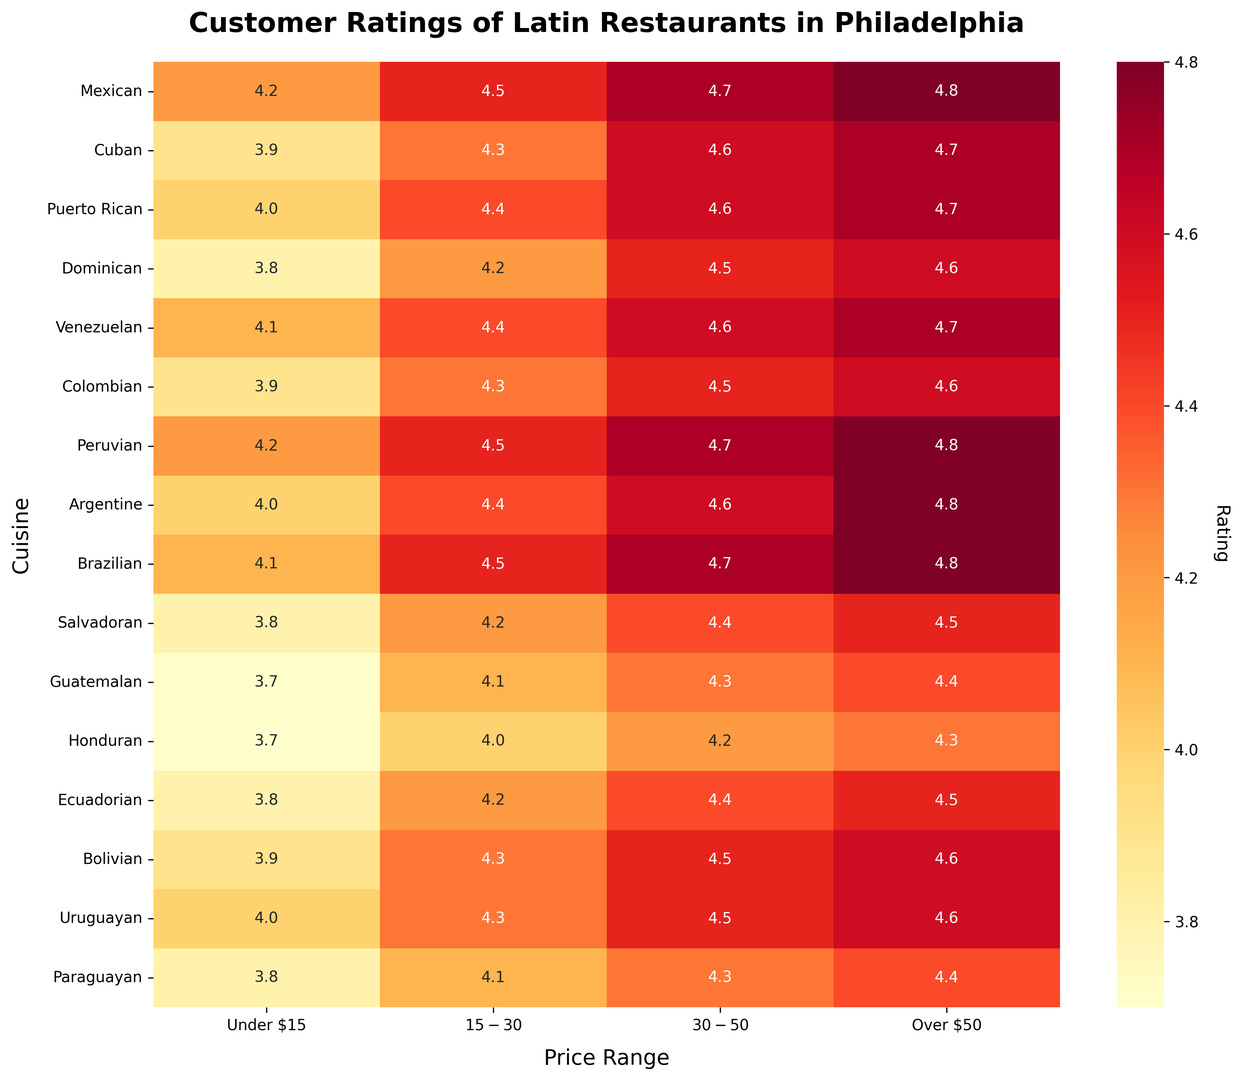What price range has the highest average rating across all cuisines? Calculate the average rating for each price range, then compare. For Under $15: (4.2+3.9+4.0+3.8+4.1+3.9+4.2+4.0+4.1+3.8+3.7+3.7+3.8+3.9+4.0+3.8)/16 = 3.9875, For $15-$30: (4.5+4.3+4.4+4.2+4.4+4.3+4.5+4.4+4.5+4.2+4.1+4.0+4.2+4.3+4.3+4.1)/16 = 4.275, For $30-$50: (4.7+4.6+4.6+4.5+4.6+4.5+4.7+4.6+4.7+4.4+4.3+4.2+4.4+4.5+4.5+4.3)/16 = 4.5125, For Over $50: (4.8+4.7+4.7+4.6+4.7+4.6+4.8+4.8+4.8+4.5+4.4+4.3+4.5+4.6+4.6+4.4)/16 = 4.6125. Hence, Over $50 has the highest average rating.
Answer: Over $50 Which cuisine has the lowest rating in the Under $15 category? Compare the ratings in the Under $15 category. The lowest value is 3.7 for both Guatemalan and Honduran cuisines.
Answer: Guatemalan, Honduran How does the rating for Mexican cuisine change as the price range increases? List the ratings for Mexican cuisine: Under $15 (4.2), $15-$30 (4.5), $30-$50 (4.7), Over $50 (4.8). The rating consistently increases as the price range goes higher.
Answer: It increases Which two cuisines have the equal rating in the $30-$50 range? Compare the ratings in the $30-$50 range, and find the two equal values. Both Cuban and Venezuelan have ratings of 4.6.
Answer: Cuban, Venezuelan What is the rating difference between the highest-rated and lowest-rated cuisine in the $15-$30 category? The highest rating is 4.5 (Mexican, Peruvian, Brazilian) and the lowest is 4.0 (Honduran). The difference is 4.5 - 4.0.
Answer: 0.5 What is the median rating for the Over $50 category across all cuisines? List the ratings for the Over $50 category and find the median: 4.8, 4.7, 4.7, 4.6, 4.7, 4.6, 4.8, 4.8, 4.8, 4.5, 4.4, 4.3, 4.5, 4.6, 4.6, 4.4. The median value is the average of the 8th and 9th values in a sorted list: (4.8 + 4.8) / 2.
Answer: 4.7 Which cuisine has the most consistent rating across all price ranges? Calculate the range of ratings for each cuisine: Mexican (4.8-4.2=0.6), Cuban (4.7-3.9=0.8), Puerto Rican (4.7-4.0=0.7), Dominican (4.6-3.8=0.8), Venezuelan (4.7-4.1=0.6), Colombian (4.6-3.9=0.7), Peruvian (4.8-4.2=0.6), Argentine (4.8-4.0=0.8), Brazilian (4.8-4.1=0.7), Salvadoran (4.5-3.8=0.7), Guatemalan (4.4-3.7=0.7), Honduran (4.3-3.7=0.6), Ecuadorian (4.5-3.8=0.7), Bolivian (4.6-3.9=0.7), Uruguayan (4.6-4.0=0.6), Paraguayan (4.4-3.8=0.6). The cuisines with the smallest range are Honduran, Mexican, Venezuelan, Peruvian, Uruguayan, Paraguayan, and Honduran.
Answer: Honduran, Mexican, Venezuelan, Peruvian, Uruguayan, Paraguayan 